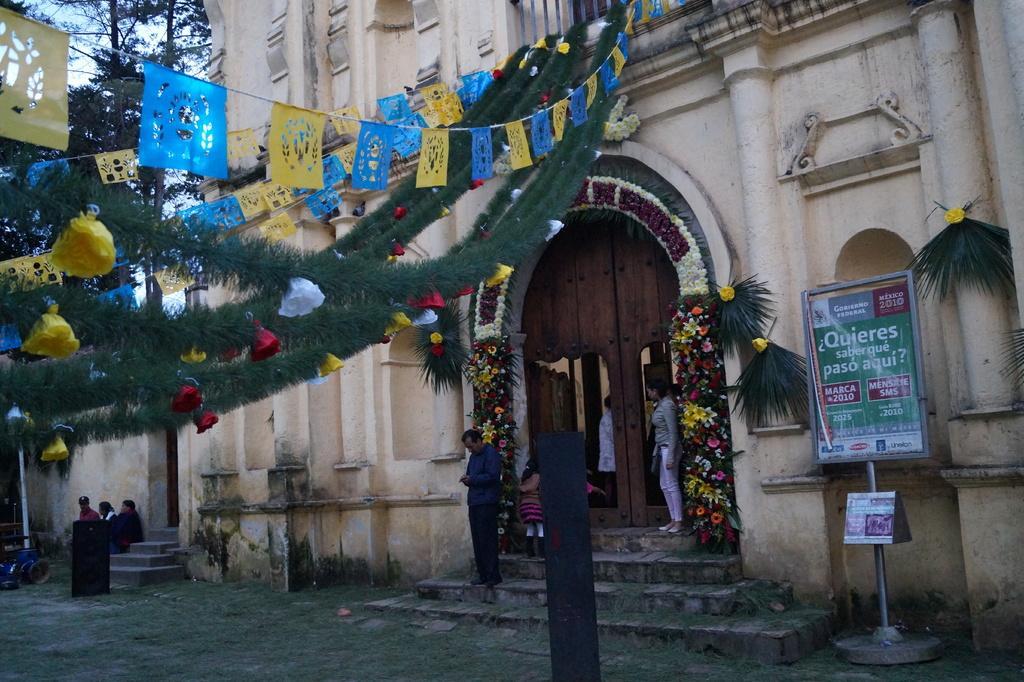How would you summarize this image in a sentence or two? In this image we can see a building with which is decorated with some flowers, flags, and some plants. We can also see a board with some text on it and some people standing on the staircase. On the left side we can see a vehicle on the ground and some people sitting. We can also see some grass, trees and the sky. 